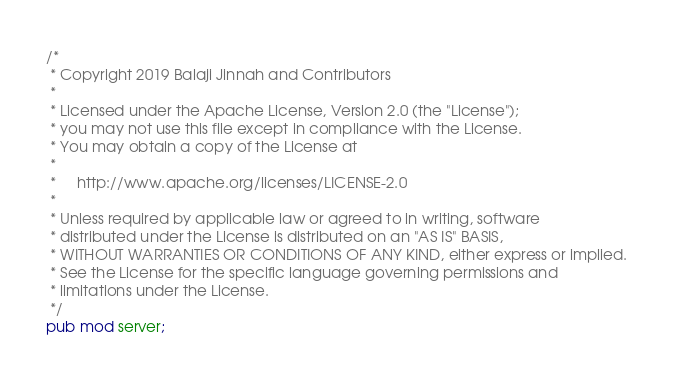<code> <loc_0><loc_0><loc_500><loc_500><_Rust_>/*
 * Copyright 2019 Balaji Jinnah and Contributors
 *
 * Licensed under the Apache License, Version 2.0 (the "License");
 * you may not use this file except in compliance with the License.
 * You may obtain a copy of the License at
 *
 *     http://www.apache.org/licenses/LICENSE-2.0
 *
 * Unless required by applicable law or agreed to in writing, software
 * distributed under the License is distributed on an "AS IS" BASIS,
 * WITHOUT WARRANTIES OR CONDITIONS OF ANY KIND, either express or implied.
 * See the License for the specific language governing permissions and
 * limitations under the License.
 */
pub mod server;
</code> 